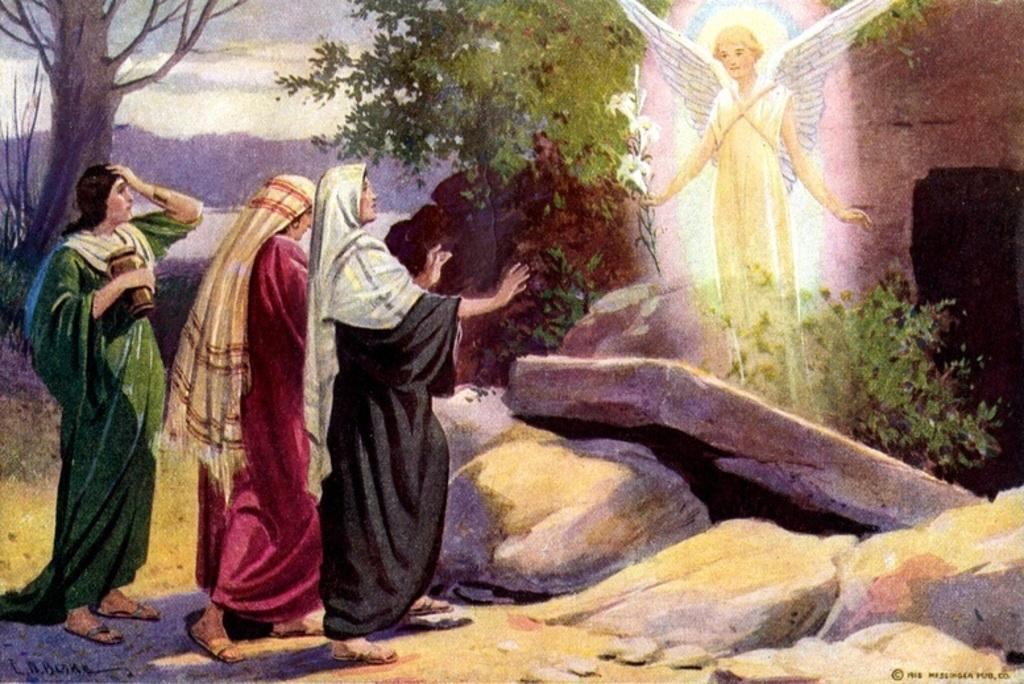What is the main subject of the image? The image contains a painting. What is depicted in the painting? The painting depicts people, rocks, trees, and plants. What can be seen in the background of the painting? The sky is visible in the background of the painting. Can you describe any other elements in the painting? There are other unspecified elements in the painting. How many pies are being held by the people in the painting? There are no pies visible in the painting; it features people, rocks, trees, plants, and an unspecified sky in the background. What type of vein is present in the painting? There is no mention of a vein in the painting; it primarily depicts people, rocks, trees, plants, and the sky. 